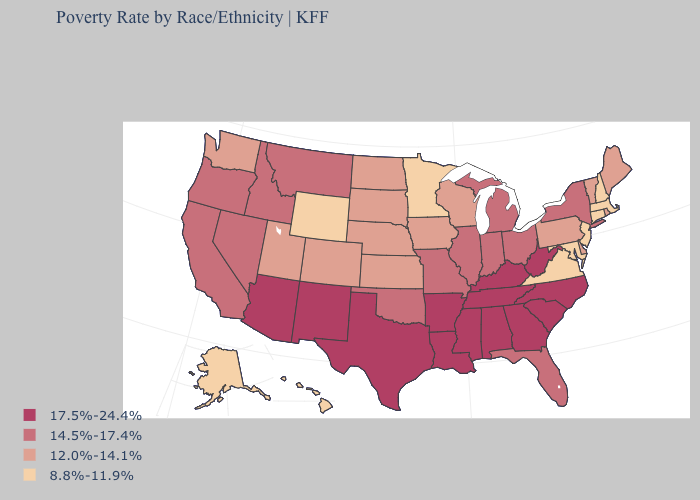Does the first symbol in the legend represent the smallest category?
Answer briefly. No. Does the map have missing data?
Keep it brief. No. Among the states that border Montana , which have the lowest value?
Quick response, please. Wyoming. Name the states that have a value in the range 8.8%-11.9%?
Concise answer only. Alaska, Connecticut, Hawaii, Maryland, Massachusetts, Minnesota, New Hampshire, New Jersey, Virginia, Wyoming. What is the value of Washington?
Concise answer only. 12.0%-14.1%. Does Wyoming have the lowest value in the USA?
Concise answer only. Yes. Does North Carolina have the lowest value in the USA?
Give a very brief answer. No. What is the highest value in the West ?
Give a very brief answer. 17.5%-24.4%. Among the states that border Montana , does Idaho have the highest value?
Be succinct. Yes. What is the lowest value in states that border Pennsylvania?
Quick response, please. 8.8%-11.9%. What is the lowest value in states that border New Mexico?
Keep it brief. 12.0%-14.1%. Name the states that have a value in the range 8.8%-11.9%?
Quick response, please. Alaska, Connecticut, Hawaii, Maryland, Massachusetts, Minnesota, New Hampshire, New Jersey, Virginia, Wyoming. What is the lowest value in states that border Georgia?
Quick response, please. 14.5%-17.4%. How many symbols are there in the legend?
Short answer required. 4. Is the legend a continuous bar?
Give a very brief answer. No. 